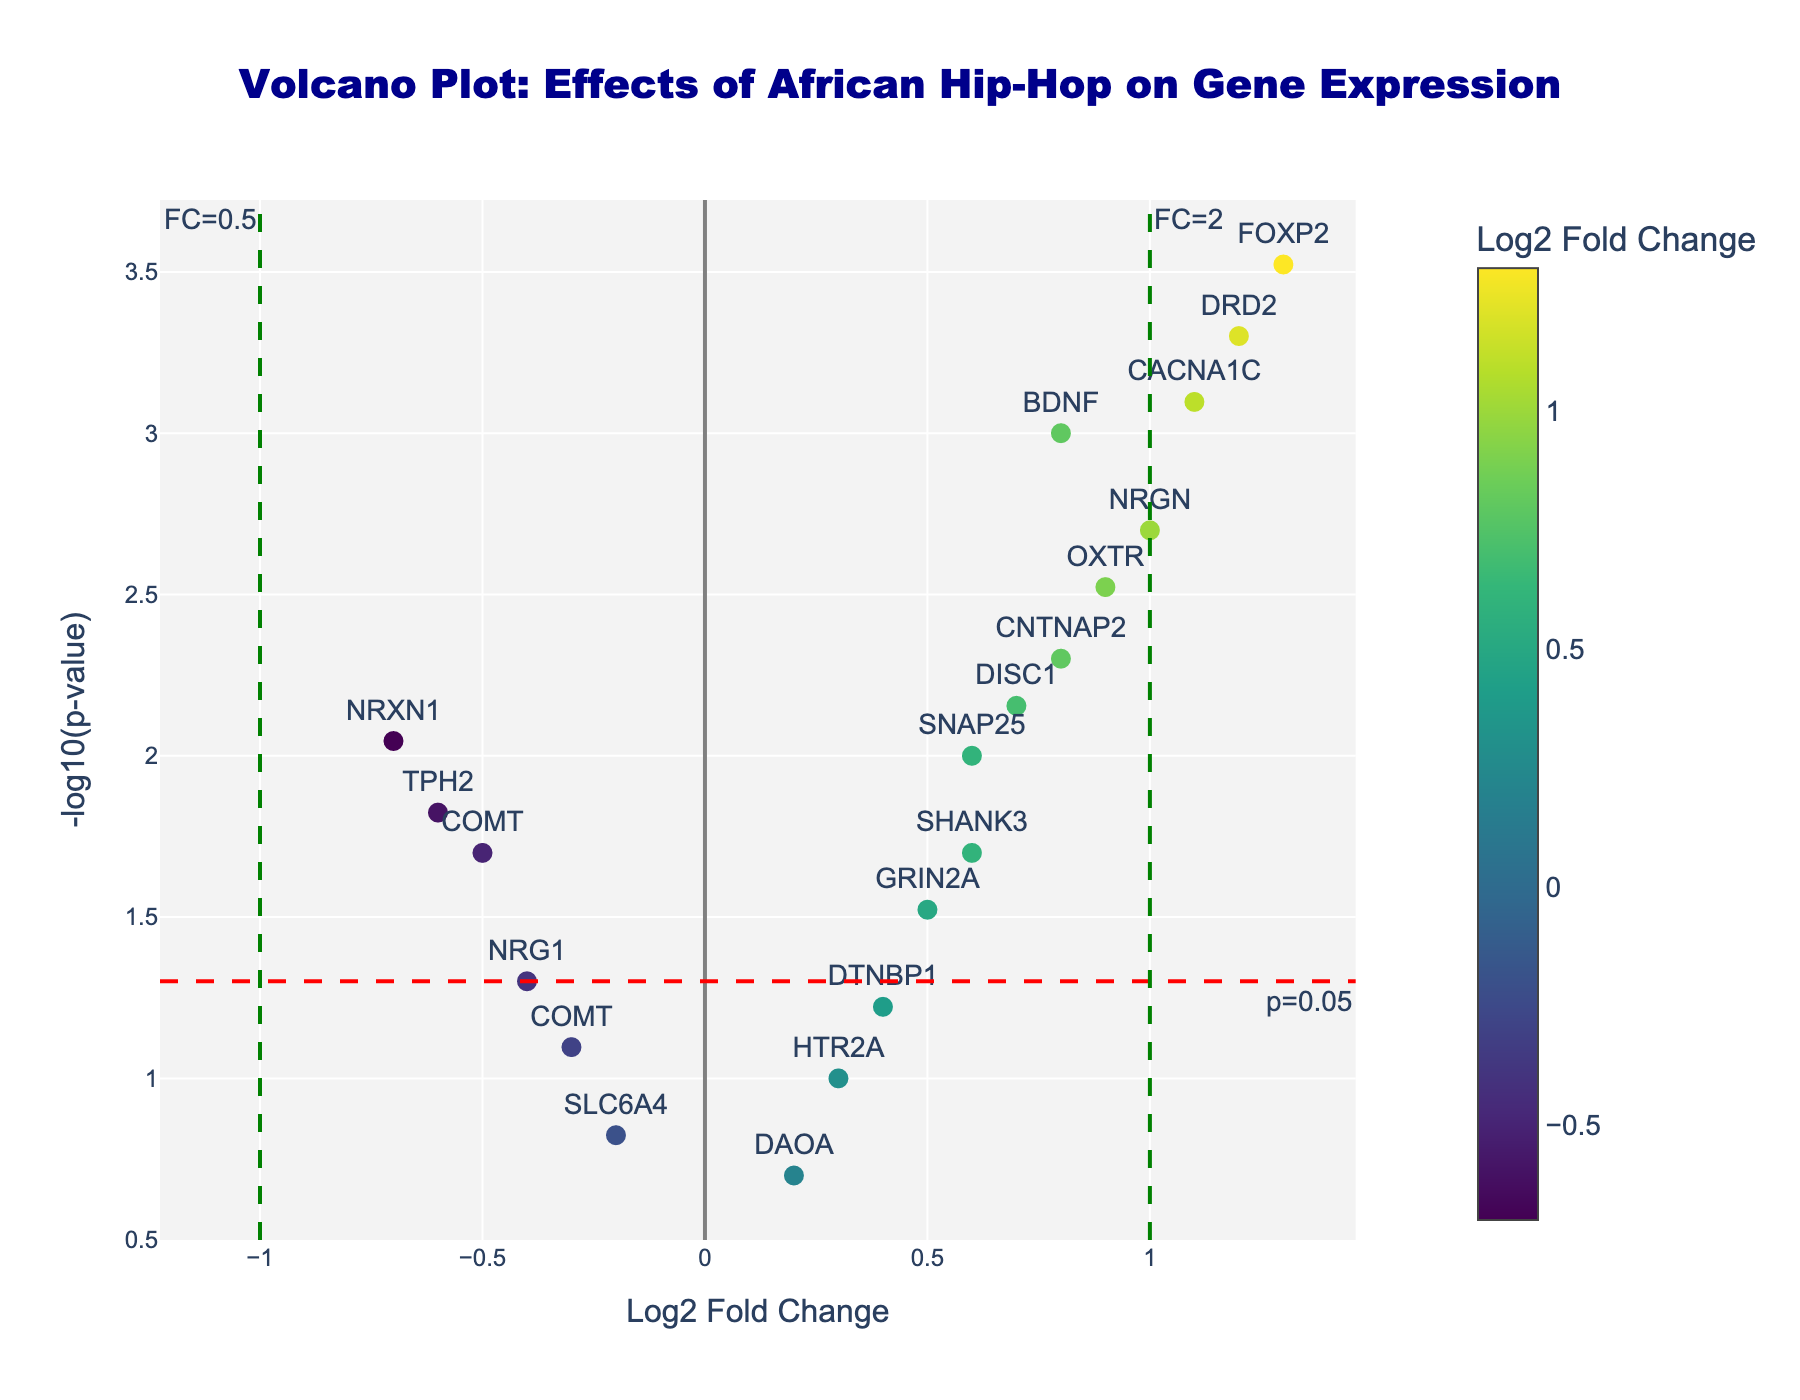How many genes have a Log2 Fold Change greater than 0? To determine the number of genes with a positive Log2 Fold Change, count all the data points with Log2 Fold Change values greater than 0. These are: BDNF, DRD2, HTR2A, OXTR, SNAP25, CACNA1C, DISC1, NRGN, GRIN2A, DTNBP1, FOXP2, and CNTNAP2.
Answer: 12 What is the significance threshold indicated on the plot? The plot features a horizontal dashed line representing the p-value threshold for significance, usually set at 0.05. The corresponding -log10(p-value) for 0.05 is 1.3, which is highlighted as a threshold on the y-axis.
Answer: p=0.05 Which gene shows the largest positive Log2 Fold Change? Identify the gene with the highest Log2 Fold Change by looking at the rightmost point on the x-axis. Among all data points, FOXP2 shows the largest positive Log2 Fold Change of 1.3.
Answer: FOXP2 How many genes are significantly regulated (p-value < 0.05)? Determine the number of data points above the horizontal dashed line at -log10(p-value) = 1.3, indicating significance. The significantly regulated genes are BDNF, DRD2, OXTR, SNAP25, CACNA1C, DISC1, NRGN, FOXP2, CNTNAP2, and NRXN1.
Answer: 10 Which gene shows the most significant p-value? The most significant p-value is indicated by the highest -log10(p) on the y-axis. The gene DRD2, located at the highest point on the y-axis, shows the most significant p-value (0.0005) with the highest -log10(p-value).
Answer: DRD2 What are the Log2 Fold Change and p-value of the gene COMT? Identify the points labeled as COMT. One point represents a Log2 Fold Change of -0.5 with a p-value of 0.02, and the other point represents a Log2 Fold Change of -0.3 with a p-value of 0.08.
Answer: (-0.5, 0.02) and (-0.3, 0.08) Are there any genes with Log2 Fold Change less than -0.5 and significant p-values? Check if there are data points to the left of -0.5 on the x-axis and above the horizontal dashed line (p-value < 0.05). Only TPH2 shows a Log2 Fold Change of -0.6 with a significant p-value of 0.015.
Answer: Yes, TPH2 How many genes show a Log2 Fold Change between -0.5 and 0? Count the data points within the x-axis range of -0.5 to 0. These genes are SLC6A4, NRG1, COMT, and DAOA.
Answer: 4 Which genes have a Log2 Fold Change greater than 1 and a p-value less than 0.005? Identify data points on the plot with Log2 Fold Changes greater than 1 and above the horizontal dashed line at -log10(p) = 1.3. These genes are DRD2, CACNA1C, and FOXP2.
Answer: DRD2, CACNA1C, FOXP2 